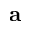<formula> <loc_0><loc_0><loc_500><loc_500>a</formula> 